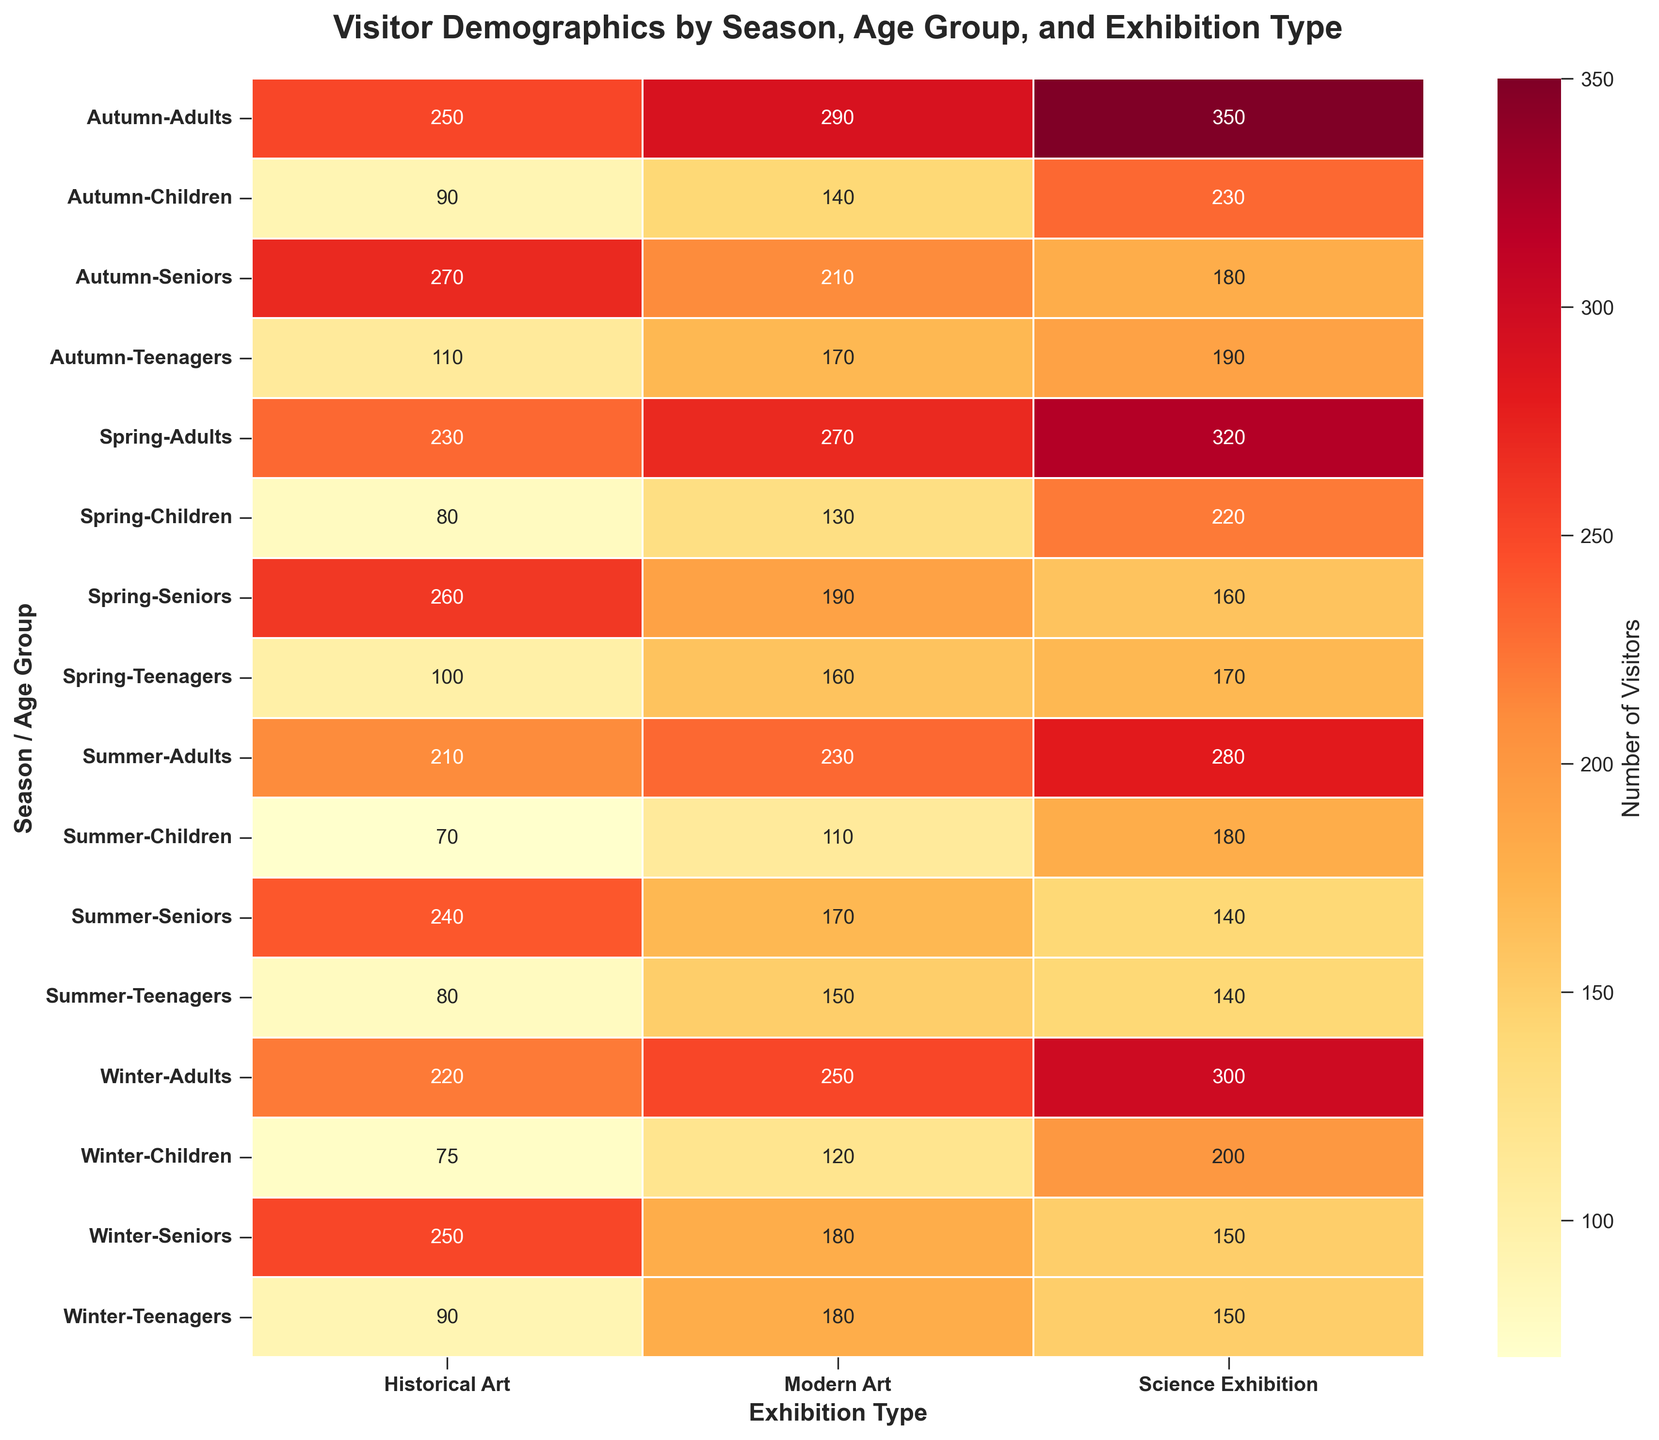What is the title of the heatmap? The title of the heatmap is located at the top, formatted in a bold font. It helps understand the context of the data being visualized, which is seen clearly on the plot.
Answer: Visitor Demographics by Season, Age Group, and Exhibition Type Which season had the highest number of adult visitors to the Science Exhibition? To determine this, look at the rows corresponding to each season under the "Adults" age group and check the values under the "Science Exhibition" column.
Answer: Autumn In which season and age group did Modern Art attract the fewest visitors? To find the season and age group with the fewest visitors to Modern Art, scan the values in the Modern Art column across all seasons and age groups to identify the minimum value.
Answer: Summer, Children How many more visitors did Historical Art attract in Spring compared to Winter for the Seniors age group? Locate the values for the Seniors age group under the Historical Art column for both Spring and Winter. Calculate the difference by subtracting the Winter value from the Spring value.
Answer: 10 Which exhibition type saw the largest variance in visitor numbers across all age groups and seasons? To determine this, observe the range of visitor numbers for each exhibition type column. The one with the largest spread between its minimum and maximum values represents the largest variance.
Answer: Science Exhibition What is the total number of visitors for the Children age group across all exhibition types in Autumn? Sum the visitor numbers for each exhibition type (Modern Art, Historical Art, Science Exhibition) for Children in Autumn to get the total number of visitors.
Answer: 460 In Spring, which exhibition type attracted the most visitors from the Teenagers age group? Check the Teenagers row for Spring and compare the visitor numbers across the three exhibition types to identify the maximum value.
Answer: Science Exhibition Is there any age group for which Historical Art is more popular than Modern Art across all seasons? Compare values for Modern Art and Historical Art columns for each age group across all seasons. If Historical Art consistently has higher visitor numbers than Modern Art for an age group, it is more popular.
Answer: Seniors Which exhibition type had the greatest increase in visitors from Winter to Spring for Adults? Subtract the number of visitors in Winter from those in Spring for each exhibition type under the Adults age group and identify the largest increase.
Answer: Science Exhibition 